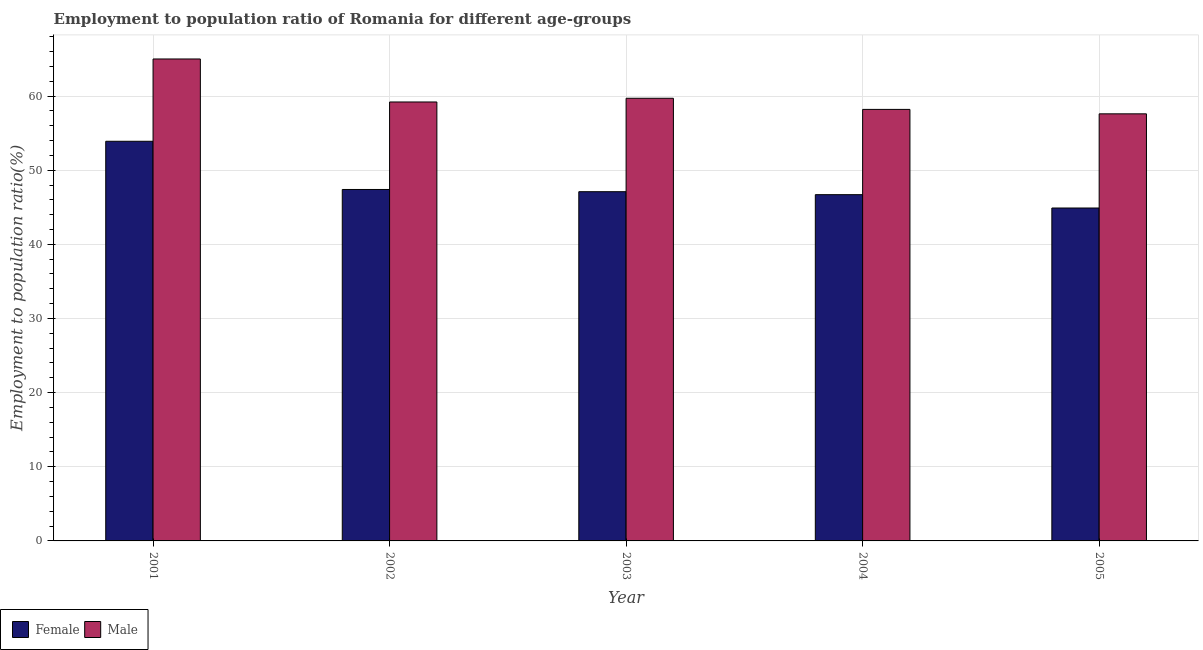How many different coloured bars are there?
Provide a short and direct response. 2. How many groups of bars are there?
Give a very brief answer. 5. Are the number of bars per tick equal to the number of legend labels?
Provide a short and direct response. Yes. How many bars are there on the 1st tick from the right?
Make the answer very short. 2. What is the label of the 2nd group of bars from the left?
Ensure brevity in your answer.  2002. In how many cases, is the number of bars for a given year not equal to the number of legend labels?
Keep it short and to the point. 0. What is the employment to population ratio(female) in 2004?
Provide a succinct answer. 46.7. Across all years, what is the minimum employment to population ratio(female)?
Offer a terse response. 44.9. In which year was the employment to population ratio(female) maximum?
Your answer should be compact. 2001. What is the total employment to population ratio(female) in the graph?
Offer a terse response. 240. What is the difference between the employment to population ratio(male) in 2004 and that in 2005?
Provide a succinct answer. 0.6. What is the difference between the employment to population ratio(male) in 2001 and the employment to population ratio(female) in 2002?
Keep it short and to the point. 5.8. What is the average employment to population ratio(male) per year?
Provide a short and direct response. 59.94. In how many years, is the employment to population ratio(female) greater than 40 %?
Offer a terse response. 5. What is the ratio of the employment to population ratio(female) in 2001 to that in 2002?
Offer a very short reply. 1.14. Is the employment to population ratio(female) in 2002 less than that in 2005?
Your answer should be compact. No. What is the difference between the highest and the second highest employment to population ratio(male)?
Provide a short and direct response. 5.3. What is the difference between the highest and the lowest employment to population ratio(male)?
Keep it short and to the point. 7.4. In how many years, is the employment to population ratio(male) greater than the average employment to population ratio(male) taken over all years?
Provide a succinct answer. 1. What does the 2nd bar from the left in 2002 represents?
Your answer should be very brief. Male. What is the difference between two consecutive major ticks on the Y-axis?
Provide a short and direct response. 10. Does the graph contain any zero values?
Your answer should be very brief. No. Does the graph contain grids?
Give a very brief answer. Yes. Where does the legend appear in the graph?
Keep it short and to the point. Bottom left. How are the legend labels stacked?
Provide a short and direct response. Horizontal. What is the title of the graph?
Offer a terse response. Employment to population ratio of Romania for different age-groups. Does "Urban" appear as one of the legend labels in the graph?
Offer a very short reply. No. What is the label or title of the X-axis?
Provide a short and direct response. Year. What is the Employment to population ratio(%) of Female in 2001?
Offer a very short reply. 53.9. What is the Employment to population ratio(%) of Male in 2001?
Your response must be concise. 65. What is the Employment to population ratio(%) of Female in 2002?
Make the answer very short. 47.4. What is the Employment to population ratio(%) in Male in 2002?
Your answer should be compact. 59.2. What is the Employment to population ratio(%) in Female in 2003?
Offer a very short reply. 47.1. What is the Employment to population ratio(%) of Male in 2003?
Keep it short and to the point. 59.7. What is the Employment to population ratio(%) of Female in 2004?
Provide a succinct answer. 46.7. What is the Employment to population ratio(%) of Male in 2004?
Provide a short and direct response. 58.2. What is the Employment to population ratio(%) in Female in 2005?
Keep it short and to the point. 44.9. What is the Employment to population ratio(%) in Male in 2005?
Give a very brief answer. 57.6. Across all years, what is the maximum Employment to population ratio(%) of Female?
Keep it short and to the point. 53.9. Across all years, what is the maximum Employment to population ratio(%) in Male?
Your response must be concise. 65. Across all years, what is the minimum Employment to population ratio(%) of Female?
Your response must be concise. 44.9. Across all years, what is the minimum Employment to population ratio(%) in Male?
Ensure brevity in your answer.  57.6. What is the total Employment to population ratio(%) in Female in the graph?
Offer a terse response. 240. What is the total Employment to population ratio(%) of Male in the graph?
Ensure brevity in your answer.  299.7. What is the difference between the Employment to population ratio(%) of Female in 2001 and that in 2002?
Your answer should be very brief. 6.5. What is the difference between the Employment to population ratio(%) of Male in 2001 and that in 2002?
Provide a succinct answer. 5.8. What is the difference between the Employment to population ratio(%) of Female in 2001 and that in 2003?
Give a very brief answer. 6.8. What is the difference between the Employment to population ratio(%) in Male in 2001 and that in 2004?
Your answer should be very brief. 6.8. What is the difference between the Employment to population ratio(%) in Female in 2002 and that in 2004?
Make the answer very short. 0.7. What is the difference between the Employment to population ratio(%) of Male in 2002 and that in 2004?
Your answer should be very brief. 1. What is the difference between the Employment to population ratio(%) of Female in 2002 and that in 2005?
Offer a very short reply. 2.5. What is the difference between the Employment to population ratio(%) of Female in 2003 and that in 2004?
Offer a very short reply. 0.4. What is the difference between the Employment to population ratio(%) of Male in 2003 and that in 2005?
Offer a very short reply. 2.1. What is the difference between the Employment to population ratio(%) of Female in 2004 and that in 2005?
Provide a succinct answer. 1.8. What is the difference between the Employment to population ratio(%) of Male in 2004 and that in 2005?
Your response must be concise. 0.6. What is the difference between the Employment to population ratio(%) of Female in 2001 and the Employment to population ratio(%) of Male in 2003?
Your response must be concise. -5.8. What is the difference between the Employment to population ratio(%) in Female in 2001 and the Employment to population ratio(%) in Male in 2004?
Give a very brief answer. -4.3. What is the difference between the Employment to population ratio(%) of Female in 2001 and the Employment to population ratio(%) of Male in 2005?
Ensure brevity in your answer.  -3.7. What is the difference between the Employment to population ratio(%) of Female in 2002 and the Employment to population ratio(%) of Male in 2003?
Your answer should be very brief. -12.3. What is the difference between the Employment to population ratio(%) of Female in 2002 and the Employment to population ratio(%) of Male in 2005?
Make the answer very short. -10.2. What is the difference between the Employment to population ratio(%) of Female in 2003 and the Employment to population ratio(%) of Male in 2004?
Provide a succinct answer. -11.1. What is the difference between the Employment to population ratio(%) in Female in 2003 and the Employment to population ratio(%) in Male in 2005?
Your answer should be very brief. -10.5. What is the difference between the Employment to population ratio(%) in Female in 2004 and the Employment to population ratio(%) in Male in 2005?
Your answer should be very brief. -10.9. What is the average Employment to population ratio(%) of Female per year?
Your response must be concise. 48. What is the average Employment to population ratio(%) in Male per year?
Your answer should be very brief. 59.94. In the year 2003, what is the difference between the Employment to population ratio(%) in Female and Employment to population ratio(%) in Male?
Keep it short and to the point. -12.6. In the year 2005, what is the difference between the Employment to population ratio(%) in Female and Employment to population ratio(%) in Male?
Offer a very short reply. -12.7. What is the ratio of the Employment to population ratio(%) in Female in 2001 to that in 2002?
Offer a terse response. 1.14. What is the ratio of the Employment to population ratio(%) in Male in 2001 to that in 2002?
Offer a terse response. 1.1. What is the ratio of the Employment to population ratio(%) of Female in 2001 to that in 2003?
Keep it short and to the point. 1.14. What is the ratio of the Employment to population ratio(%) of Male in 2001 to that in 2003?
Your answer should be very brief. 1.09. What is the ratio of the Employment to population ratio(%) in Female in 2001 to that in 2004?
Give a very brief answer. 1.15. What is the ratio of the Employment to population ratio(%) of Male in 2001 to that in 2004?
Ensure brevity in your answer.  1.12. What is the ratio of the Employment to population ratio(%) of Female in 2001 to that in 2005?
Keep it short and to the point. 1.2. What is the ratio of the Employment to population ratio(%) in Male in 2001 to that in 2005?
Your answer should be compact. 1.13. What is the ratio of the Employment to population ratio(%) of Female in 2002 to that in 2003?
Provide a succinct answer. 1.01. What is the ratio of the Employment to population ratio(%) of Female in 2002 to that in 2004?
Offer a very short reply. 1.01. What is the ratio of the Employment to population ratio(%) of Male in 2002 to that in 2004?
Provide a short and direct response. 1.02. What is the ratio of the Employment to population ratio(%) of Female in 2002 to that in 2005?
Offer a terse response. 1.06. What is the ratio of the Employment to population ratio(%) of Male in 2002 to that in 2005?
Provide a short and direct response. 1.03. What is the ratio of the Employment to population ratio(%) of Female in 2003 to that in 2004?
Ensure brevity in your answer.  1.01. What is the ratio of the Employment to population ratio(%) in Male in 2003 to that in 2004?
Offer a very short reply. 1.03. What is the ratio of the Employment to population ratio(%) in Female in 2003 to that in 2005?
Give a very brief answer. 1.05. What is the ratio of the Employment to population ratio(%) of Male in 2003 to that in 2005?
Provide a succinct answer. 1.04. What is the ratio of the Employment to population ratio(%) of Female in 2004 to that in 2005?
Offer a very short reply. 1.04. What is the ratio of the Employment to population ratio(%) of Male in 2004 to that in 2005?
Provide a succinct answer. 1.01. What is the difference between the highest and the second highest Employment to population ratio(%) in Female?
Offer a terse response. 6.5. What is the difference between the highest and the second highest Employment to population ratio(%) of Male?
Your answer should be very brief. 5.3. What is the difference between the highest and the lowest Employment to population ratio(%) of Female?
Your answer should be compact. 9. 